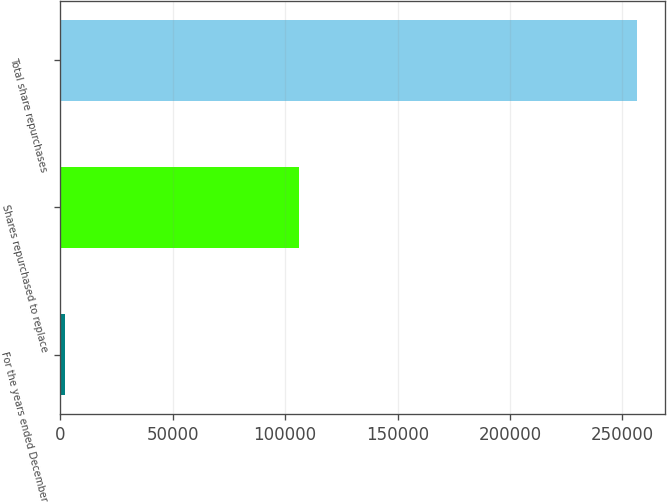Convert chart. <chart><loc_0><loc_0><loc_500><loc_500><bar_chart><fcel>For the years ended December<fcel>Shares repurchased to replace<fcel>Total share repurchases<nl><fcel>2007<fcel>106302<fcel>256285<nl></chart> 